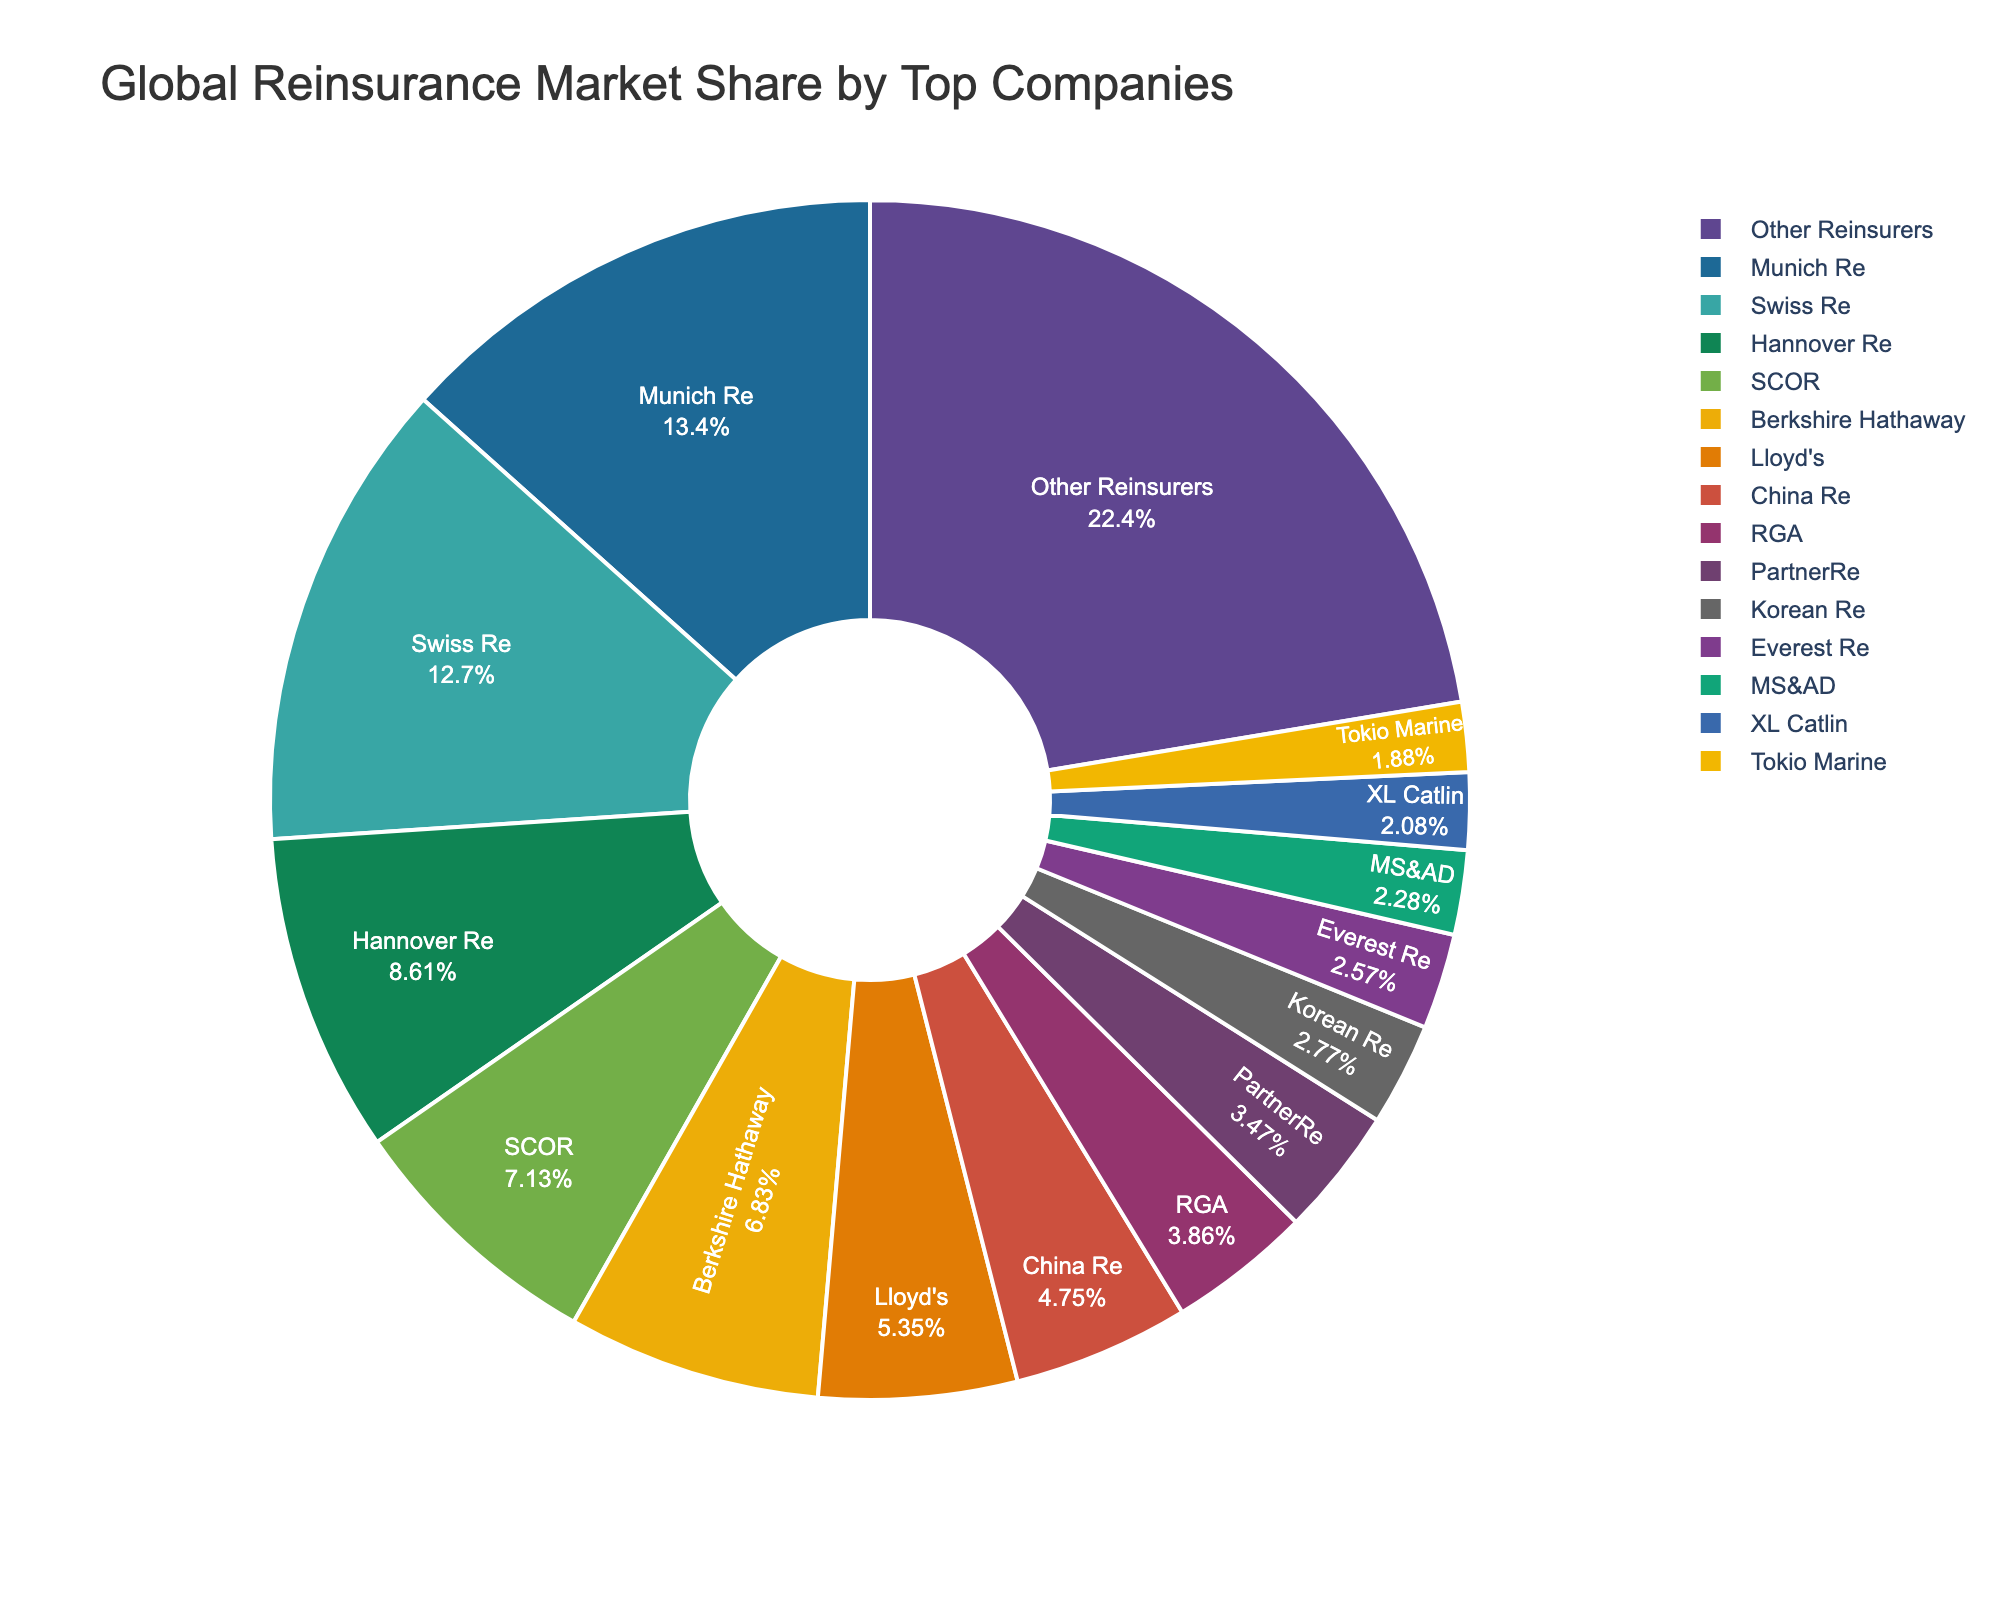what is the combined market share of Munich Re and Swiss Re? Munich Re has a market share of 13.5%, and Swiss Re has a market share of 12.8%. Adding these together: 13.5% + 12.8% = 26.3%
Answer: 26.3% Which company has a larger market share, Hannover Re or SCOR? Hannover Re has a market share of 8.7%, while SCOR has a market share of 7.2%. Therefore, Hannover Re has a larger market share than SCOR.
Answer: Hannover Re How much more market share does Munich Re have compared to PartnerRe? Munich Re has a market share of 13.5% and PartnerRe has a market share of 3.5%. Subtracting PartnerRe's share from Munich Re's: 13.5% - 3.5% = 10%
Answer: 10% What is the total market share of the companies with less than 5% market share? The companies with less than 5% market share are China Re (4.8%), RGA (3.9%), PartnerRe (3.5%), Korean Re (2.8%), Everest Re (2.6%), MS&AD (2.3%), XL Catlin (2.1%), and Tokio Marine (1.9%). Adding these together: 4.8% + 3.9% + 3.5% + 2.8% + 2.6% + 2.3% + 2.1% + 1.9% = 24%.
Answer: 24% Which company appears in red on the pie chart? The color red is typically distinct and noticeable on a pie chart. Assuming the custom color palette matches common conventions and without viewing the chart directly, the exact answer may vary.
Answer: Unknown without visual context Is the market share of ‘Other Reinsurers’ greater than the combined market share of Lloyd’s and Berkshire Hathaway? ‘Other Reinsurers’ have a market share of 22.6%. Lloyd’s has a market share of 5.4% and Berkshire Hathaway has a market share of 6.9%. The combined market share of Lloyd’s and Berkshire Hathaway is: 5.4% + 6.9% = 12.3%. Since 22.6% > 12.3%, the market share of ‘Other Reinsurers’ is greater.
Answer: Yes How does the market share of China Re compare to that of RGA? China Re has a market share of 4.8% while RGA has a market share of 3.9%. China Re has a higher market share than RGA.
Answer: China Re What is the average market share of the listed companies excluding ‘Other Reinsurers’? The market shares excluding ‘Other Reinsurers’ are: 13.5%, 12.8%, 8.7%, 7.2%, 6.9%, 5.4%, 4.8%, 3.9%, 3.5%, 2.8%, 2.6%, 2.3%, 2.1%, and 1.9%. Summing these gives: 78.4%. The number of companies is 14. So, the average is 78.4% / 14 ≈ 5.6%.
Answer: 5.6% Which company has the smallest market share and what is that share? Tokio Marine has the smallest market share of 1.9%.
Answer: Tokio Marine, 1.9% If the market shares of Hannover Re and MS&AD are combined, what percentage of market share would it represent? Hannover Re has a market share of 8.7%, and MS&AD has a market share of 2.3%. Combining these: 8.7% + 2.3% = 11%.
Answer: 11% 